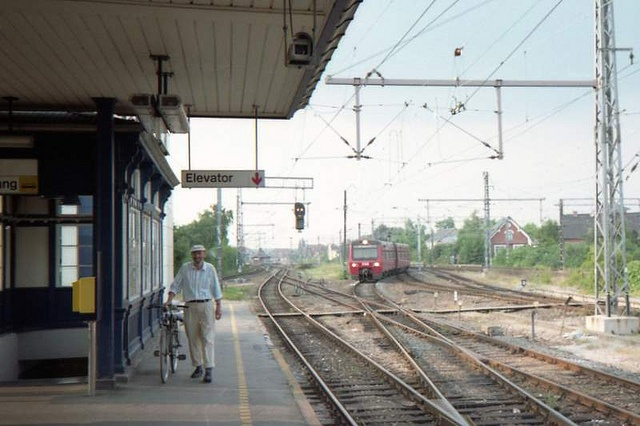Describe the objects in this image and their specific colors. I can see people in black, gray, and darkgray tones, train in black, gray, and darkgray tones, bicycle in black, gray, and darkgray tones, and traffic light in black, gray, lightgray, and darkgray tones in this image. 